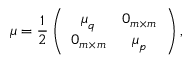Convert formula to latex. <formula><loc_0><loc_0><loc_500><loc_500>\mu = \frac { 1 } { 2 } \left ( \begin{array} { c c } { \mu _ { q } } & { 0 _ { m \times m } } \\ { 0 _ { m \times m } } & { \mu _ { p } } \end{array} \right ) ,</formula> 